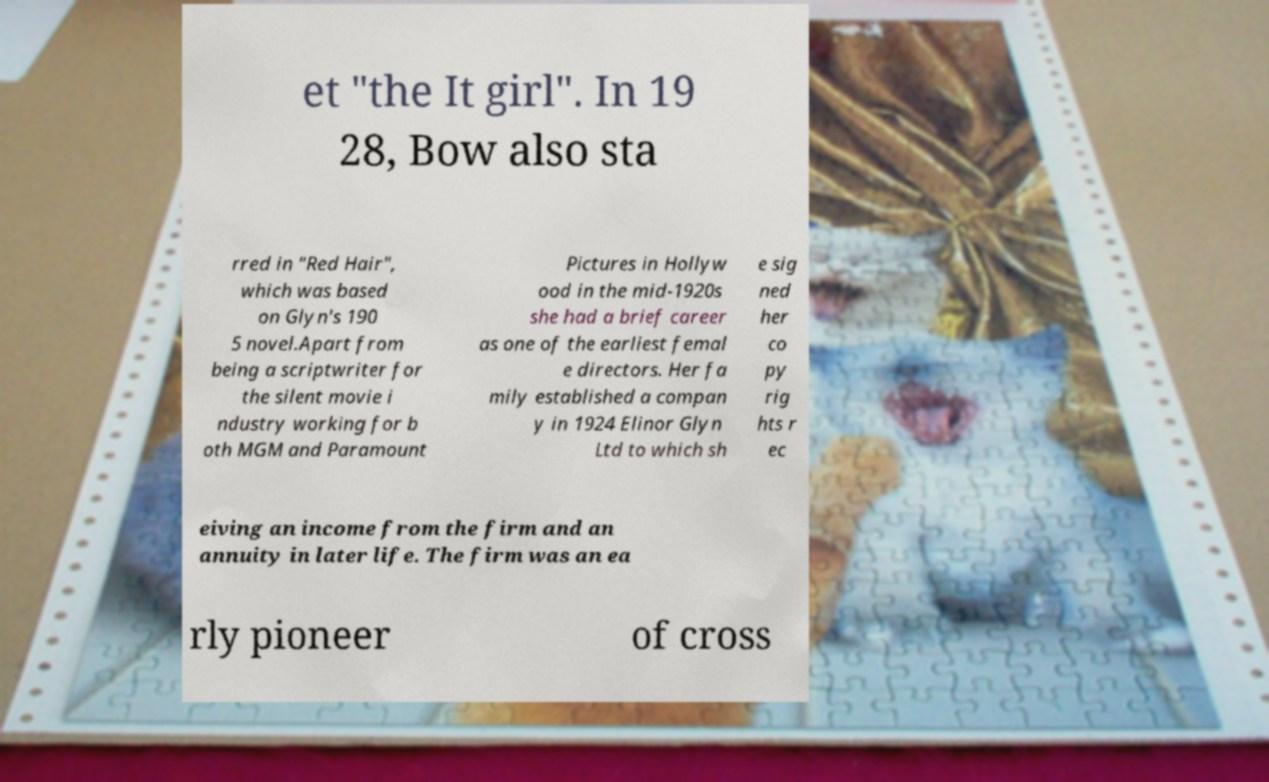Please identify and transcribe the text found in this image. et "the It girl". In 19 28, Bow also sta rred in "Red Hair", which was based on Glyn's 190 5 novel.Apart from being a scriptwriter for the silent movie i ndustry working for b oth MGM and Paramount Pictures in Hollyw ood in the mid-1920s she had a brief career as one of the earliest femal e directors. Her fa mily established a compan y in 1924 Elinor Glyn Ltd to which sh e sig ned her co py rig hts r ec eiving an income from the firm and an annuity in later life. The firm was an ea rly pioneer of cross 